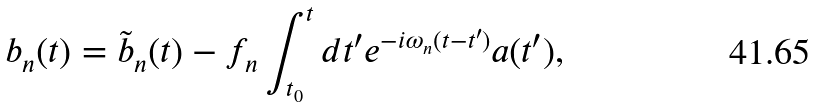Convert formula to latex. <formula><loc_0><loc_0><loc_500><loc_500>b _ { n } ( t ) = \tilde { b } _ { n } ( t ) - f _ { n } \int _ { t _ { 0 } } ^ { t } d t ^ { \prime } e ^ { - i \omega _ { n } ( t - t ^ { \prime } ) } a ( t ^ { \prime } ) ,</formula> 